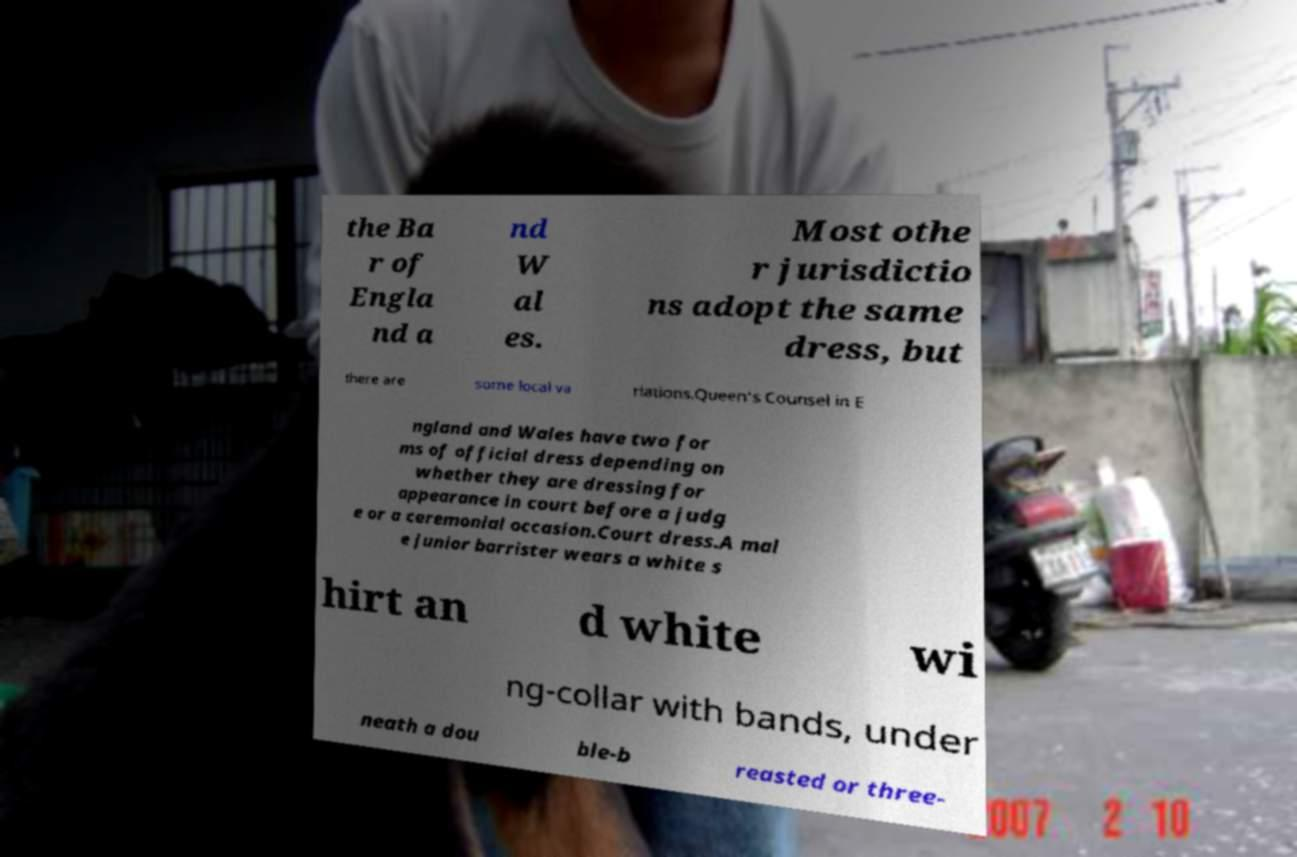Please identify and transcribe the text found in this image. the Ba r of Engla nd a nd W al es. Most othe r jurisdictio ns adopt the same dress, but there are some local va riations.Queen's Counsel in E ngland and Wales have two for ms of official dress depending on whether they are dressing for appearance in court before a judg e or a ceremonial occasion.Court dress.A mal e junior barrister wears a white s hirt an d white wi ng-collar with bands, under neath a dou ble-b reasted or three- 